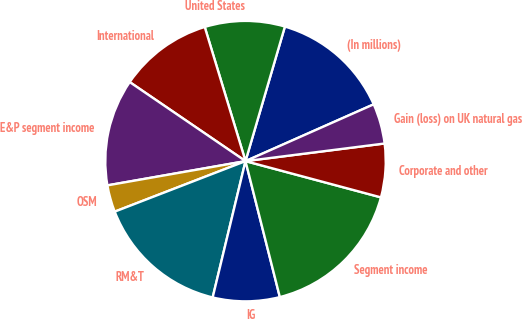<chart> <loc_0><loc_0><loc_500><loc_500><pie_chart><fcel>(In millions)<fcel>United States<fcel>International<fcel>E&P segment income<fcel>OSM<fcel>RM&T<fcel>IG<fcel>Segment income<fcel>Corporate and other<fcel>Gain (loss) on UK natural gas<nl><fcel>13.83%<fcel>9.23%<fcel>10.77%<fcel>12.3%<fcel>3.1%<fcel>15.37%<fcel>7.7%<fcel>16.9%<fcel>6.17%<fcel>4.63%<nl></chart> 